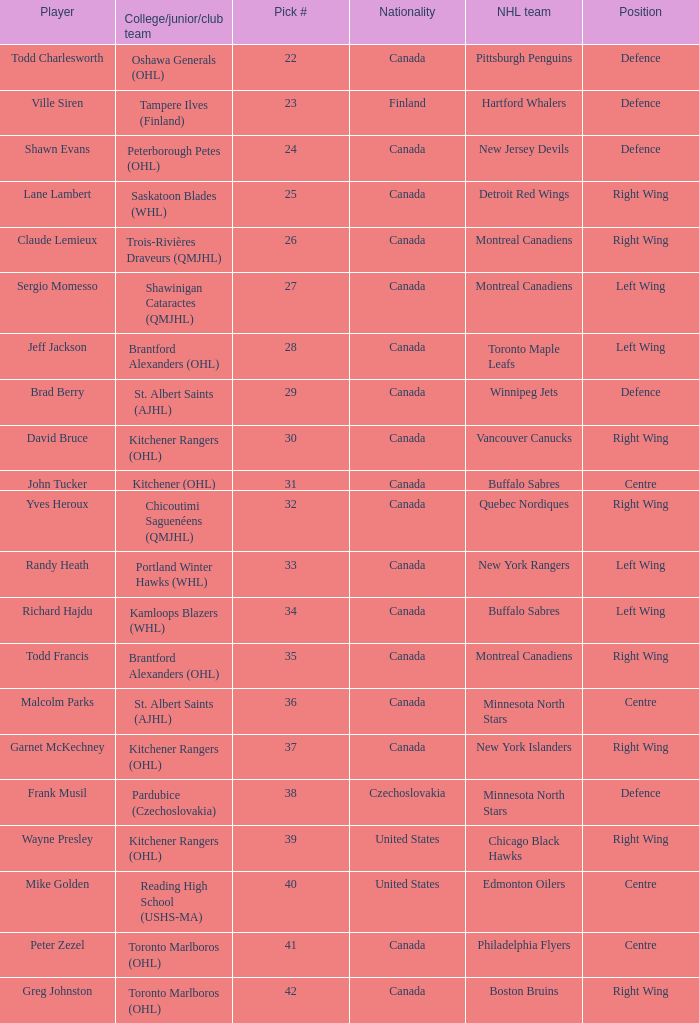How many times is the nhl team the winnipeg jets? 1.0. 